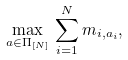<formula> <loc_0><loc_0><loc_500><loc_500>\max _ { a \in \Pi _ { [ N ] } } \, \sum _ { i = 1 } ^ { N } m _ { i , a _ { i } } ,</formula> 